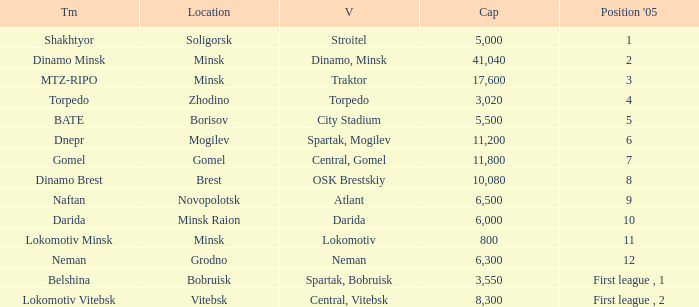Can you tell me the highest Capacity that has the Team of torpedo? 3020.0. Would you mind parsing the complete table? {'header': ['Tm', 'Location', 'V', 'Cap', "Position '05"], 'rows': [['Shakhtyor', 'Soligorsk', 'Stroitel', '5,000', '1'], ['Dinamo Minsk', 'Minsk', 'Dinamo, Minsk', '41,040', '2'], ['MTZ-RIPO', 'Minsk', 'Traktor', '17,600', '3'], ['Torpedo', 'Zhodino', 'Torpedo', '3,020', '4'], ['BATE', 'Borisov', 'City Stadium', '5,500', '5'], ['Dnepr', 'Mogilev', 'Spartak, Mogilev', '11,200', '6'], ['Gomel', 'Gomel', 'Central, Gomel', '11,800', '7'], ['Dinamo Brest', 'Brest', 'OSK Brestskiy', '10,080', '8'], ['Naftan', 'Novopolotsk', 'Atlant', '6,500', '9'], ['Darida', 'Minsk Raion', 'Darida', '6,000', '10'], ['Lokomotiv Minsk', 'Minsk', 'Lokomotiv', '800', '11'], ['Neman', 'Grodno', 'Neman', '6,300', '12'], ['Belshina', 'Bobruisk', 'Spartak, Bobruisk', '3,550', 'First league , 1'], ['Lokomotiv Vitebsk', 'Vitebsk', 'Central, Vitebsk', '8,300', 'First league , 2']]} 